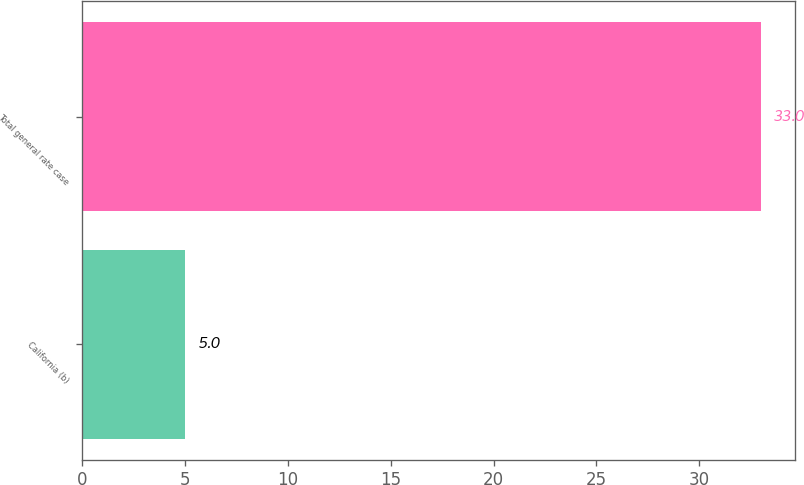Convert chart to OTSL. <chart><loc_0><loc_0><loc_500><loc_500><bar_chart><fcel>California (b)<fcel>Total general rate case<nl><fcel>5<fcel>33<nl></chart> 